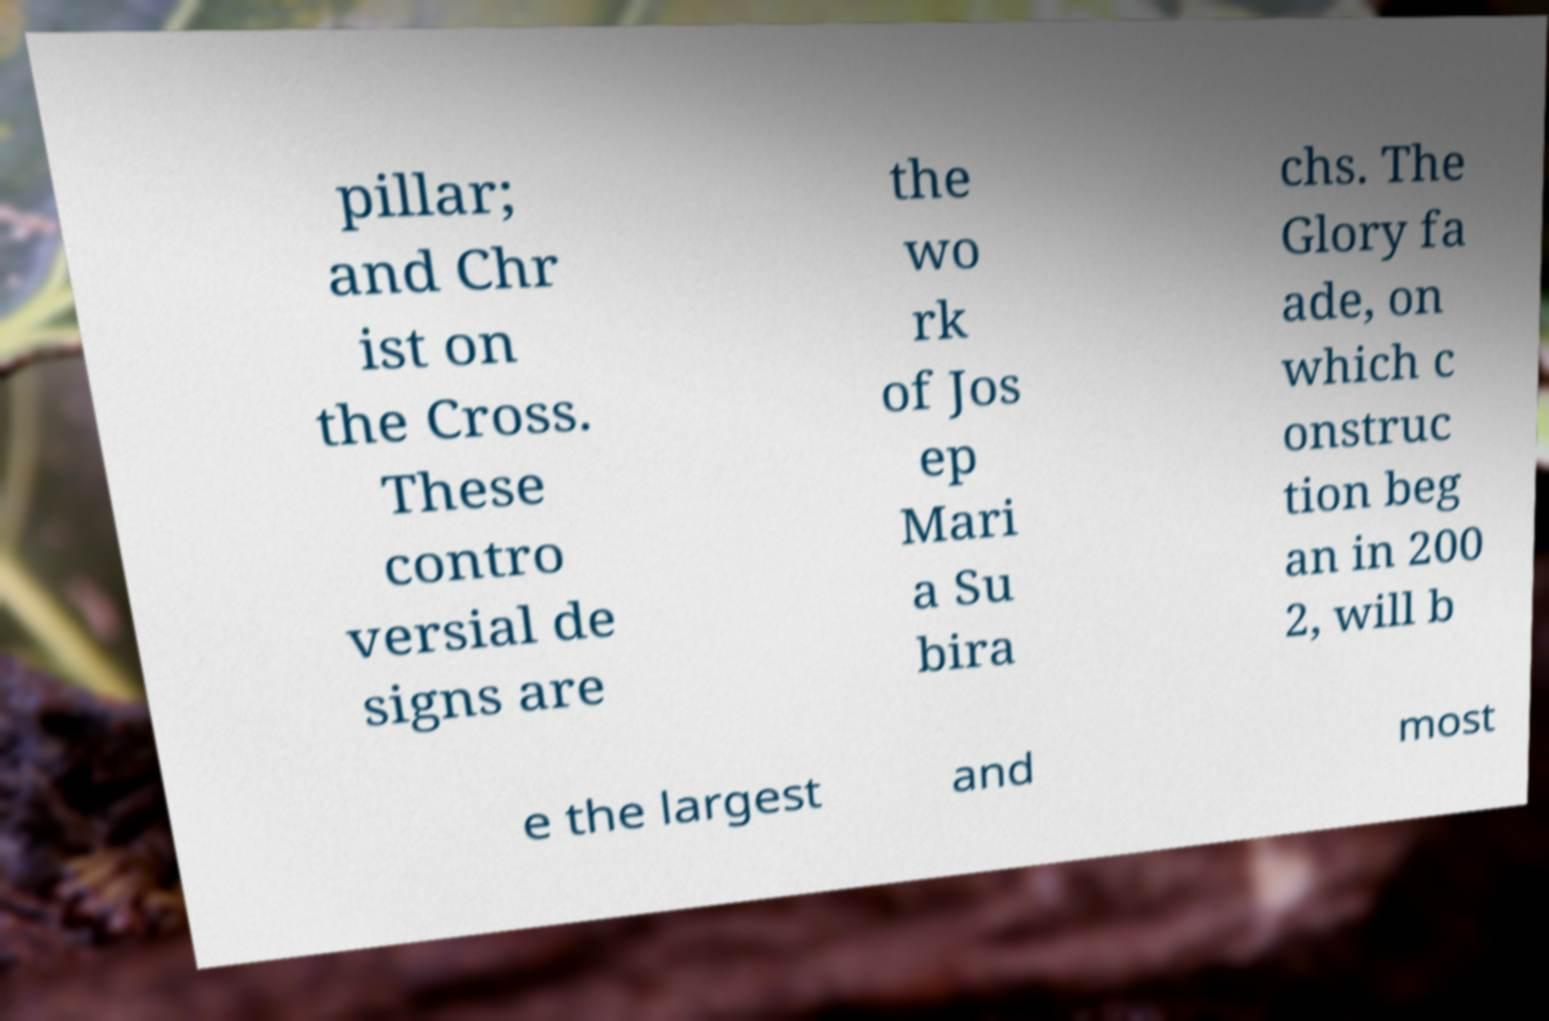Can you read and provide the text displayed in the image?This photo seems to have some interesting text. Can you extract and type it out for me? pillar; and Chr ist on the Cross. These contro versial de signs are the wo rk of Jos ep Mari a Su bira chs. The Glory fa ade, on which c onstruc tion beg an in 200 2, will b e the largest and most 